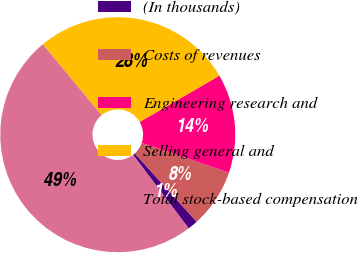Convert chart. <chart><loc_0><loc_0><loc_500><loc_500><pie_chart><fcel>(In thousands)<fcel>Costs of revenues<fcel>Engineering research and<fcel>Selling general and<fcel>Total stock-based compensation<nl><fcel>1.42%<fcel>8.04%<fcel>13.61%<fcel>27.64%<fcel>49.29%<nl></chart> 